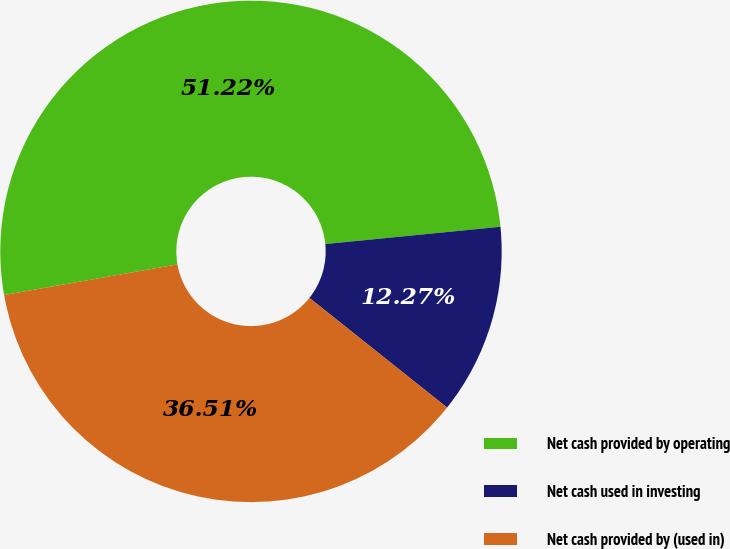<chart> <loc_0><loc_0><loc_500><loc_500><pie_chart><fcel>Net cash provided by operating<fcel>Net cash used in investing<fcel>Net cash provided by (used in)<nl><fcel>51.22%<fcel>12.27%<fcel>36.51%<nl></chart> 